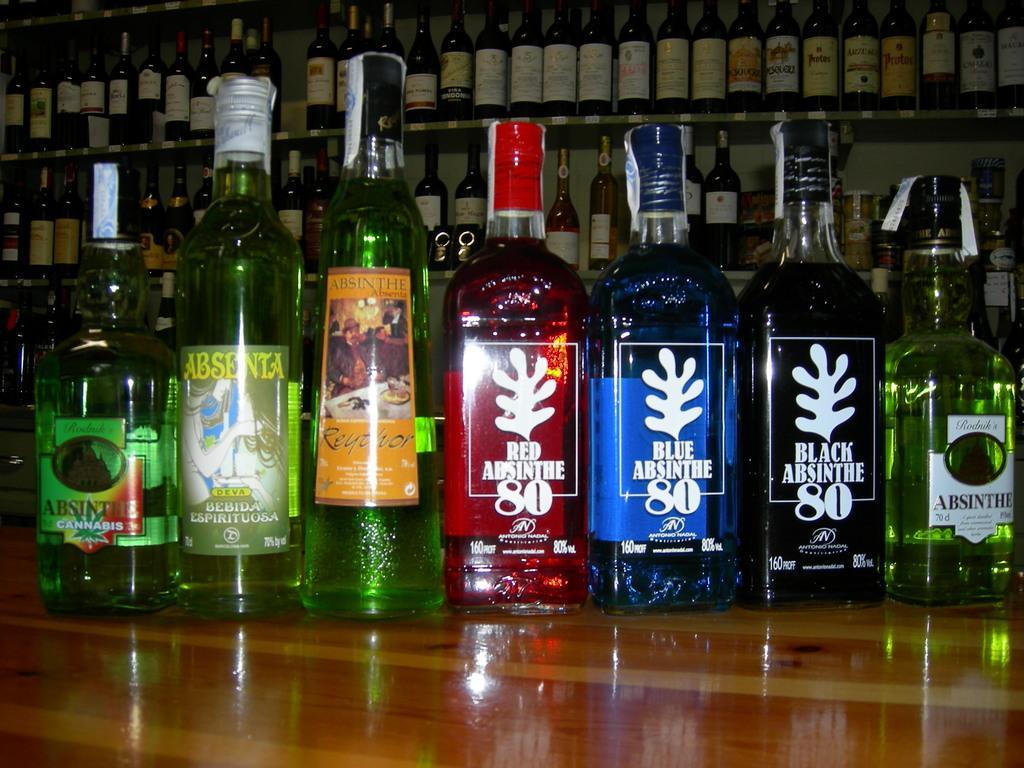Describe this image in one or two sentences. In this picture there are group of bottle on a wooden table. Background of this bottles is a shelf filled with so many wine bottles. 